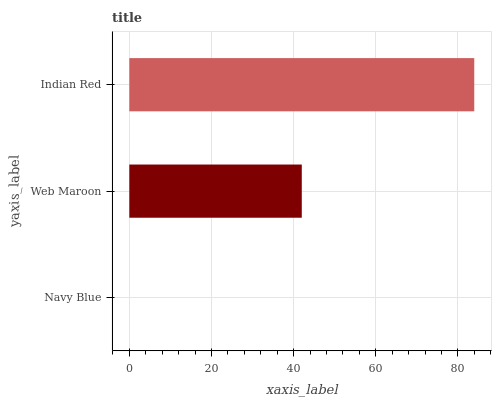Is Navy Blue the minimum?
Answer yes or no. Yes. Is Indian Red the maximum?
Answer yes or no. Yes. Is Web Maroon the minimum?
Answer yes or no. No. Is Web Maroon the maximum?
Answer yes or no. No. Is Web Maroon greater than Navy Blue?
Answer yes or no. Yes. Is Navy Blue less than Web Maroon?
Answer yes or no. Yes. Is Navy Blue greater than Web Maroon?
Answer yes or no. No. Is Web Maroon less than Navy Blue?
Answer yes or no. No. Is Web Maroon the high median?
Answer yes or no. Yes. Is Web Maroon the low median?
Answer yes or no. Yes. Is Indian Red the high median?
Answer yes or no. No. Is Indian Red the low median?
Answer yes or no. No. 